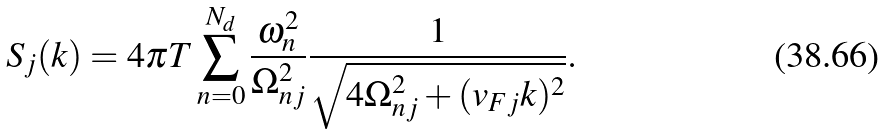<formula> <loc_0><loc_0><loc_500><loc_500>S _ { j } ( k ) = 4 \pi T \sum _ { n = 0 } ^ { N _ { d } } \frac { \omega _ { n } ^ { 2 } } { \Omega _ { n j } ^ { 2 } } \frac { 1 } { \sqrt { 4 \Omega _ { n j } ^ { 2 } + ( v _ { F j } k ) ^ { 2 } } } .</formula> 